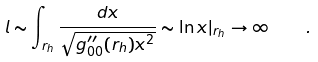Convert formula to latex. <formula><loc_0><loc_0><loc_500><loc_500>l \sim \int _ { r _ { h } } \frac { d x } { \sqrt { g ^ { \prime \prime } _ { 0 0 } ( r _ { h } ) x ^ { 2 } } } \sim \ln x | _ { r _ { h } } \rightarrow \infty \quad .</formula> 